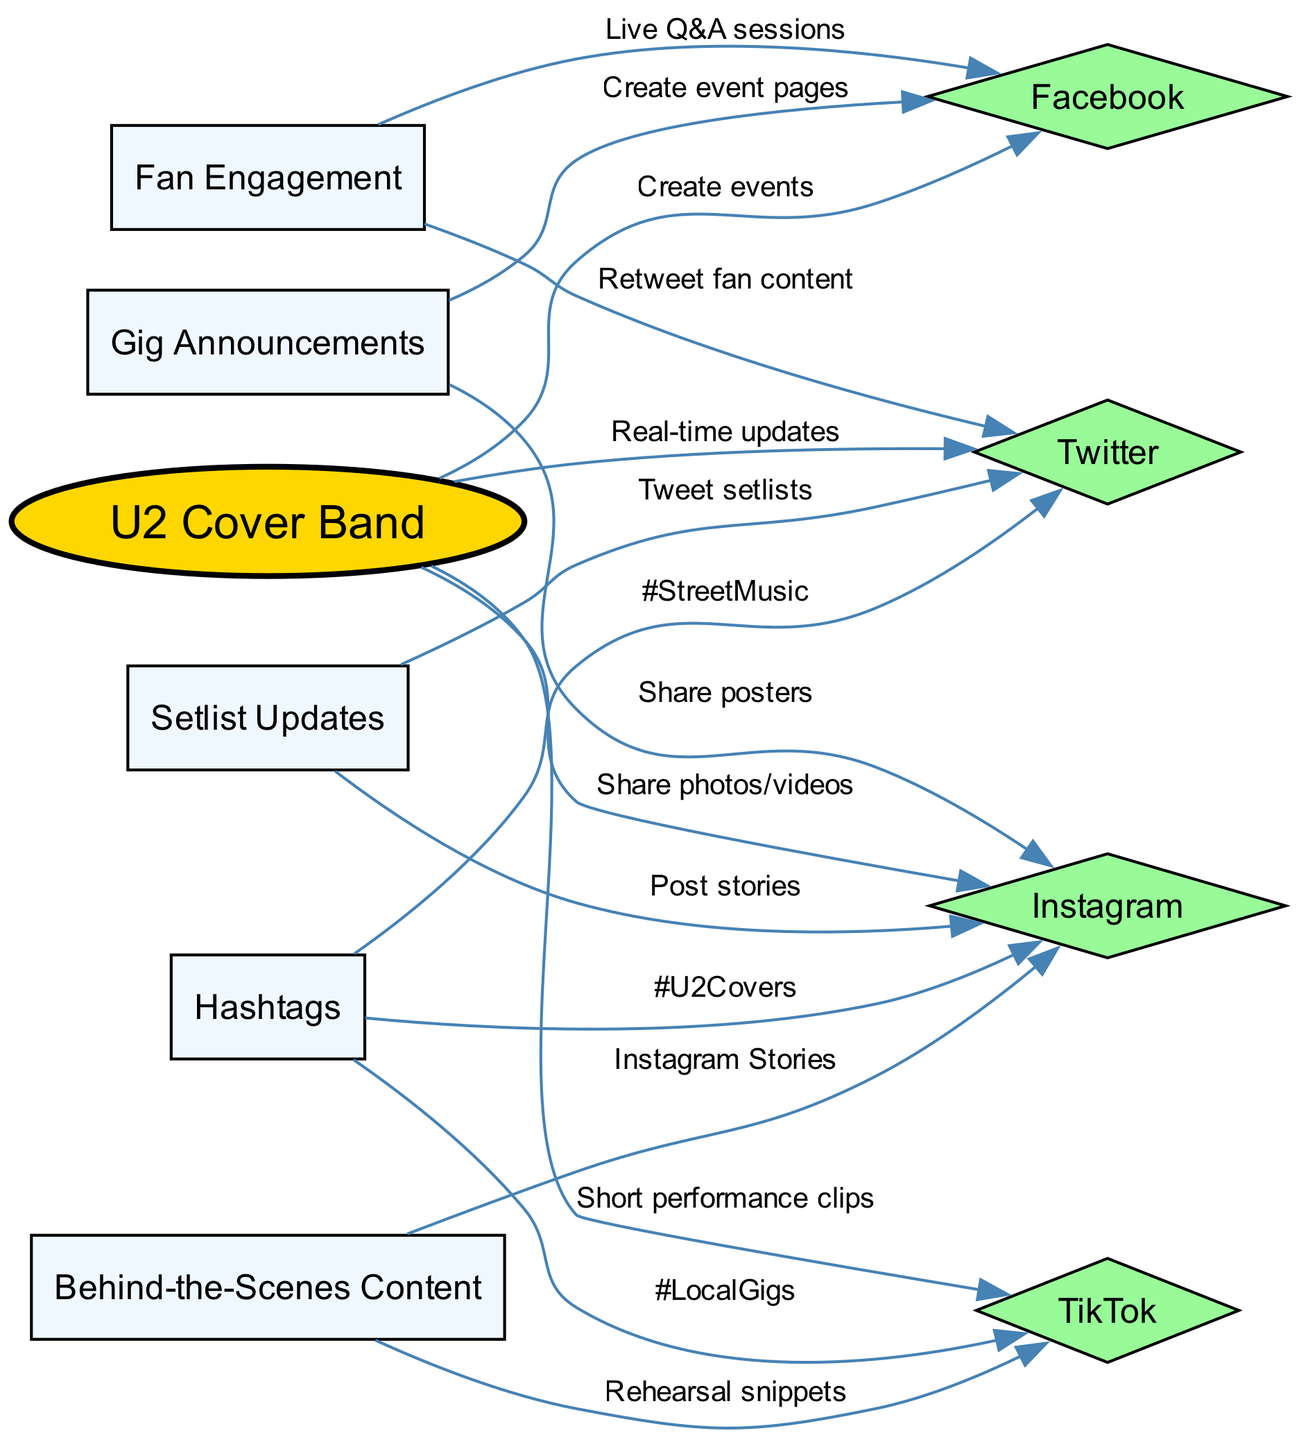What is the main subject of the concept map? The main subject is the "U2 Cover Band," which is represented as the central node in the diagram. All other nodes connect to it, indicating the relationships and strategies surrounding it.
Answer: U2 Cover Band How many social media platforms are listed? The diagram includes four social media platforms: Instagram, Facebook, Twitter, and TikTok. By counting the nodes with those labels, we can verify the total.
Answer: 4 What kind of content is shared on Instagram? The edges leading from the "U2 Cover Band" to the "Instagram" node specify that "Share photos/videos" and "Instagram Stories" are shared content. Therefore, it involves visual content as indicated in the relationships.
Answer: Photos/Videos, Stories Which node is connected to the "Setlist Updates" node? The "Setlist Updates" node connects to two platforms: Instagram for "Post stories" and Twitter for "Tweet setlists." This indicates that updates will be communicated through those channels.
Answer: Instagram, Twitter How many edges connect to the "Gig Announcements" node? "Gig Announcements" connects to two nodes: Facebook for "Create event pages" and Instagram for "Share posters." By counting these connections, we find the number of edges.
Answer: 2 What content type is shared on TikTok? The edge from "U2 Cover Band" to "TikTok" mentions "Short performance clips," indicating that performance clips provide the content shared there, specifically focusing on brief showcases.
Answer: Short performance clips What strategy involves "Fan Engagement"? "Fan Engagement" has connections to Facebook for "Live Q&A sessions" and Twitter for "Retweet fan content." This strategy thus emphasizes interacting directly with fans via these platforms.
Answer: Live Q&A sessions, Retweet fan content Which hashtag is associated with Instagram in the diagram? The hashtag "#U2Covers" connects directly to Instagram, as indicated by the edge to the social media platform's node, emphasizing its use for categorization or promotion.
Answer: #U2Covers How do behind-the-scenes content connect to social media? "Behind-the-Scenes Content" connects to TikTok for "Rehearsal snippets" and Instagram for "Instagram Stories," indicating that behind-the-scenes material is shared via these platforms to engage audiences.
Answer: TikTok, Instagram 